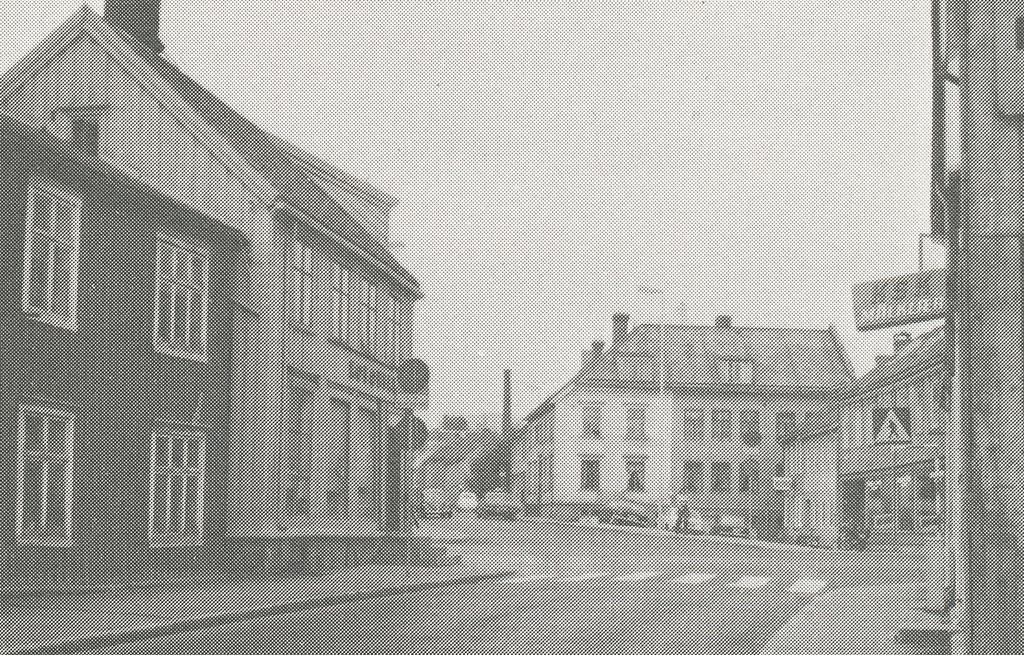How would you summarize this image in a sentence or two? In this image there are buildings, vehicles and there are boards with some text written on it. 